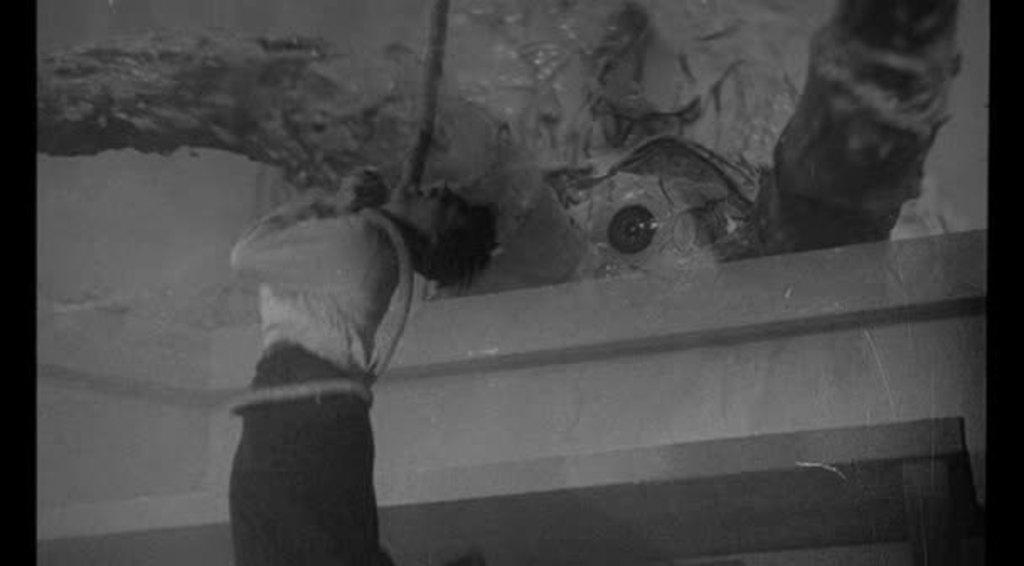What is the main subject of the image? There is a person in the image. What is the person's condition in the image? The person appears to be tied with a rope. Can you describe the background of the image? There are other objects visible in the background of the image. What type of skirt is the person wearing in the image? There is no skirt visible in the image, as the person is tied with a rope. Can you describe the person's running speed in the image? The person is not running in the image, as they are tied with a rope. 